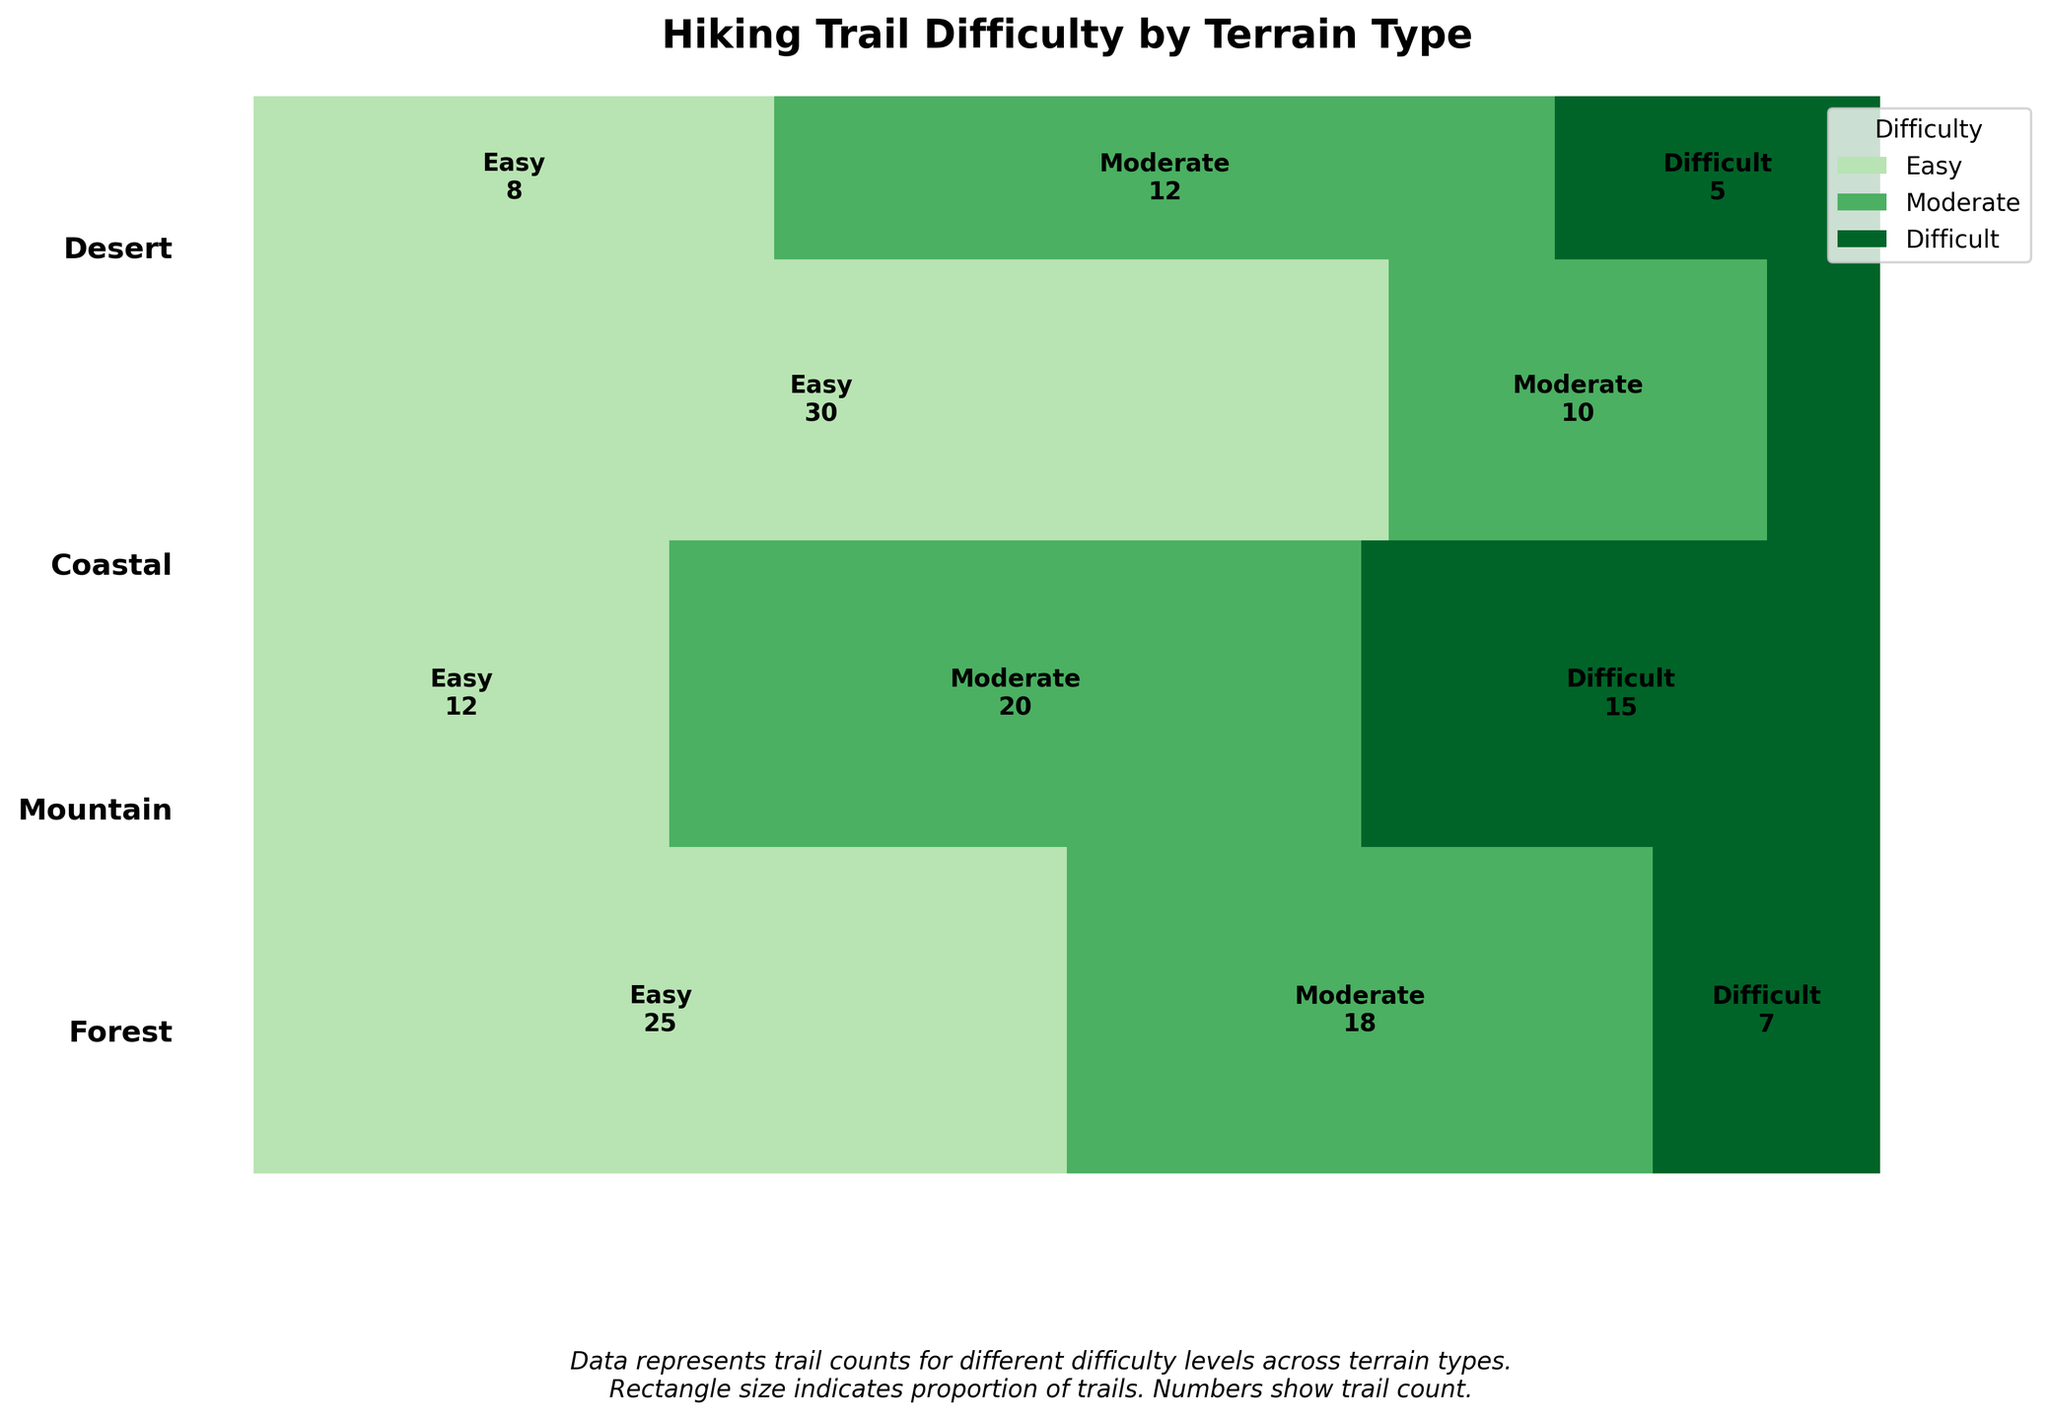What is the title of the plot? The title is usually displayed at the top of the figure. In this case, it reads "Hiking Trail Difficulty by Terrain Type".
Answer: Hiking Trail Difficulty by Terrain Type Which terrain type has the highest total number of trails? The total number of trails for each terrain type is shown by the height of the rectangles representing each terrain. The tallest rectangle corresponds to the Coastal terrain.
Answer: Coastal Which terrain has the most "Easy" trails? Look at the width of the "Easy" (low elevation gain) section for each terrain type. The Coastal terrain has the widest section for "Easy" trails.
Answer: Coastal What is the proportion of "Difficult" trails in the Mountain terrain? The total height of the Mountain terrain segment represents 100% of Mountain trails. The width of the "Difficult" (high elevation gain) part within this segment represents the proportion of "Difficult" trails. It occupies approximately one-third of the height.
Answer: Approximately 1/3 Which terrain type has the fewest "Difficult" trails? Look at the width of the "Difficult" (high elevation gain) section for each terrain type. The narrowest section for "Difficult" trails corresponds to the Coastal terrain.
Answer: Coastal What is the total number of "Moderate" trails in the plot? Add up the numbers shown within the "Moderate" sections for each terrain type: Forest (18), Mountain (20), Coastal (10), and Desert (12). The total is 18 + 20 + 10 + 12 = 60.
Answer: 60 Compare the number of "Easy" trails in Forest and Desert terrains. Which has more? Compare the numbers in the "Easy" trail sections for Forest (25) and Desert (8). Forest has more "Easy" trails.
Answer: Forest Which terrain type has the most balanced distribution of trails across all difficulty levels? The most balanced distribution can be seen where the rectangles for all difficulty levels (Easy, Moderate, Difficult) are closest in width. The Mountain terrain appears most balanced, with relatively equal widths for all difficulty sections.
Answer: Mountain How does the number of "Moderate" trails in the Desert terrain compare to the number of "Difficult" trails in the same terrain? Look at the numbers within the Desert terrain section. There are 12 "Moderate" trails and 5 "Difficult" trails, making "Moderate" trails more than twice as many as "Difficult" trails.
Answer: "Moderate" trails are more than twice as many 